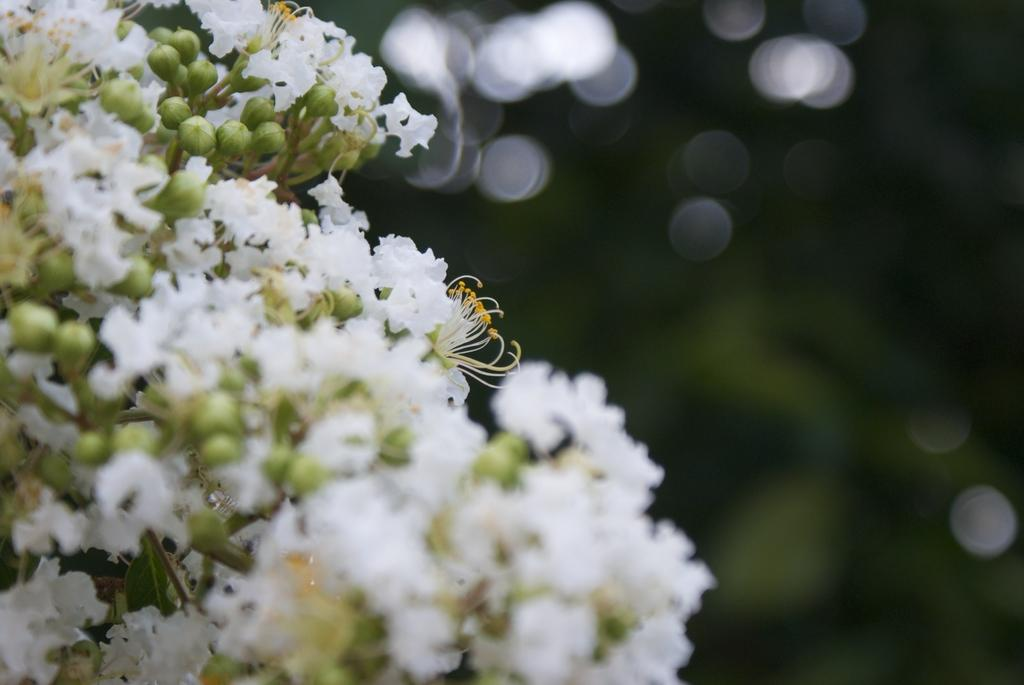What type of flowers can be seen in the image? There are white color flowers in the image. Can you describe the background of the image? The background of the image is blurred and dark. What role does the fireman play in the image? There is no fireman present in the image. How does the war affect the flowers in the image? There is no war present in the image, and therefore no impact on the flowers can be observed. 